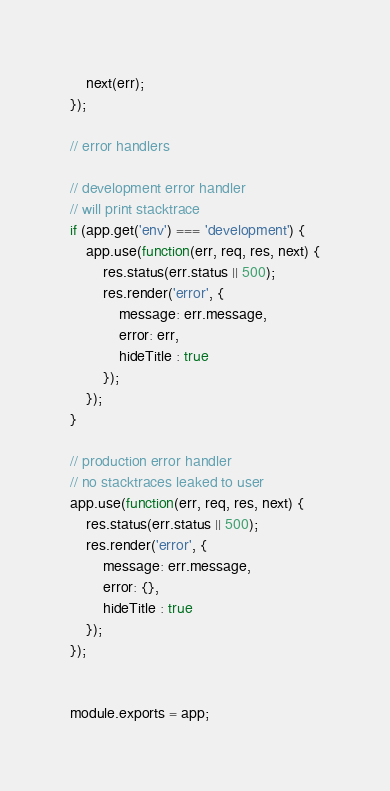Convert code to text. <code><loc_0><loc_0><loc_500><loc_500><_JavaScript_>    next(err);
});

// error handlers

// development error handler
// will print stacktrace
if (app.get('env') === 'development') {
    app.use(function(err, req, res, next) {
        res.status(err.status || 500);
        res.render('error', {
            message: err.message,
            error: err,
            hideTitle : true
        });
    });
}

// production error handler
// no stacktraces leaked to user
app.use(function(err, req, res, next) {
    res.status(err.status || 500);
    res.render('error', {
        message: err.message,
        error: {},
        hideTitle : true
    });
});


module.exports = app;
</code> 